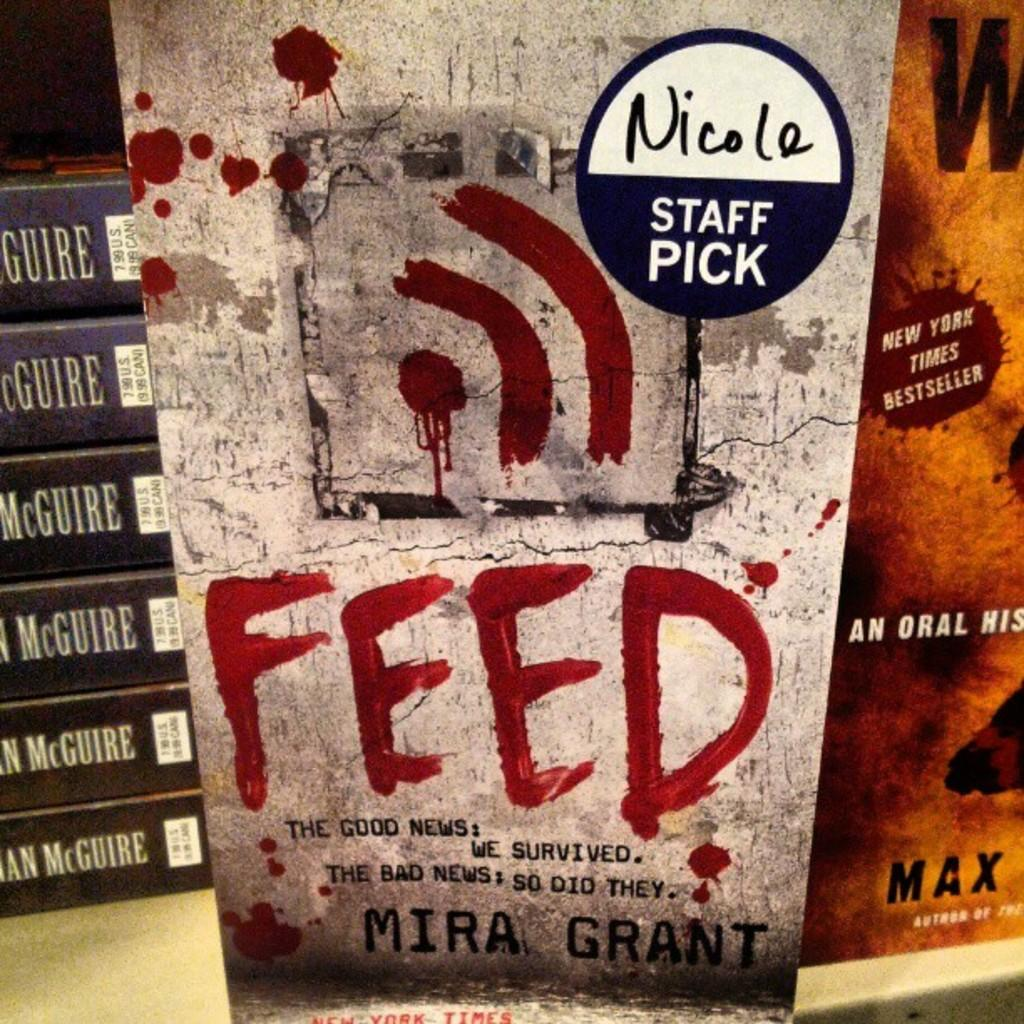Provide a one-sentence caption for the provided image. A sticker from Nicole's Staff picks is on the book Feed by Mira Grant. 